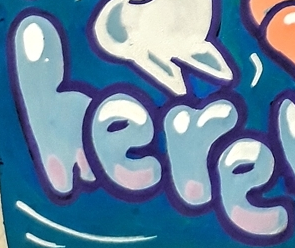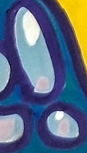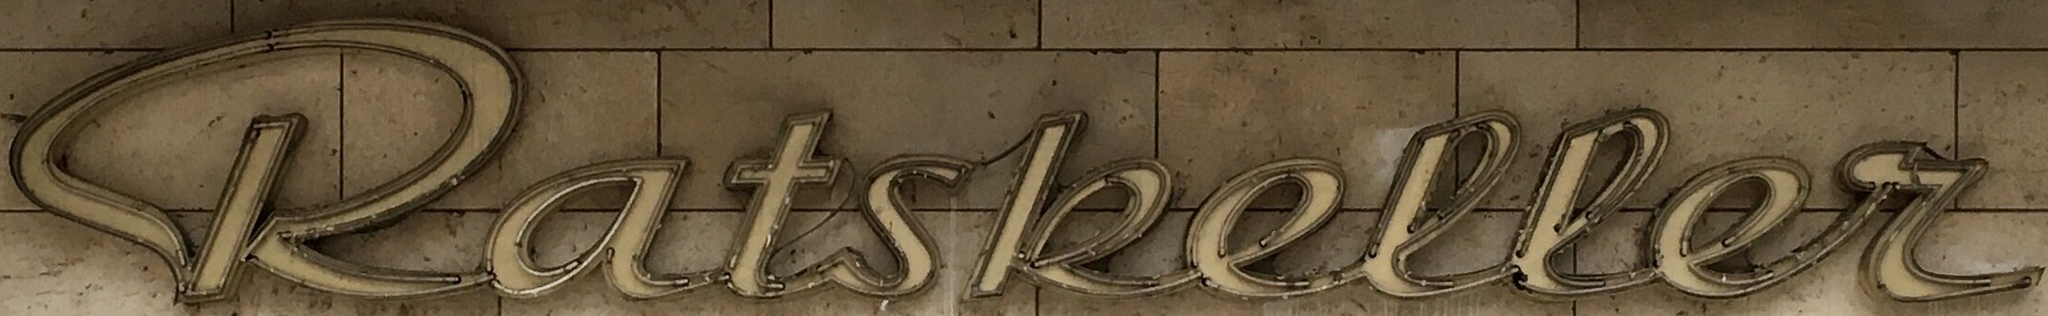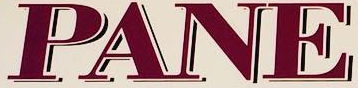Identify the words shown in these images in order, separated by a semicolon. here; !; katskeller; PANE 